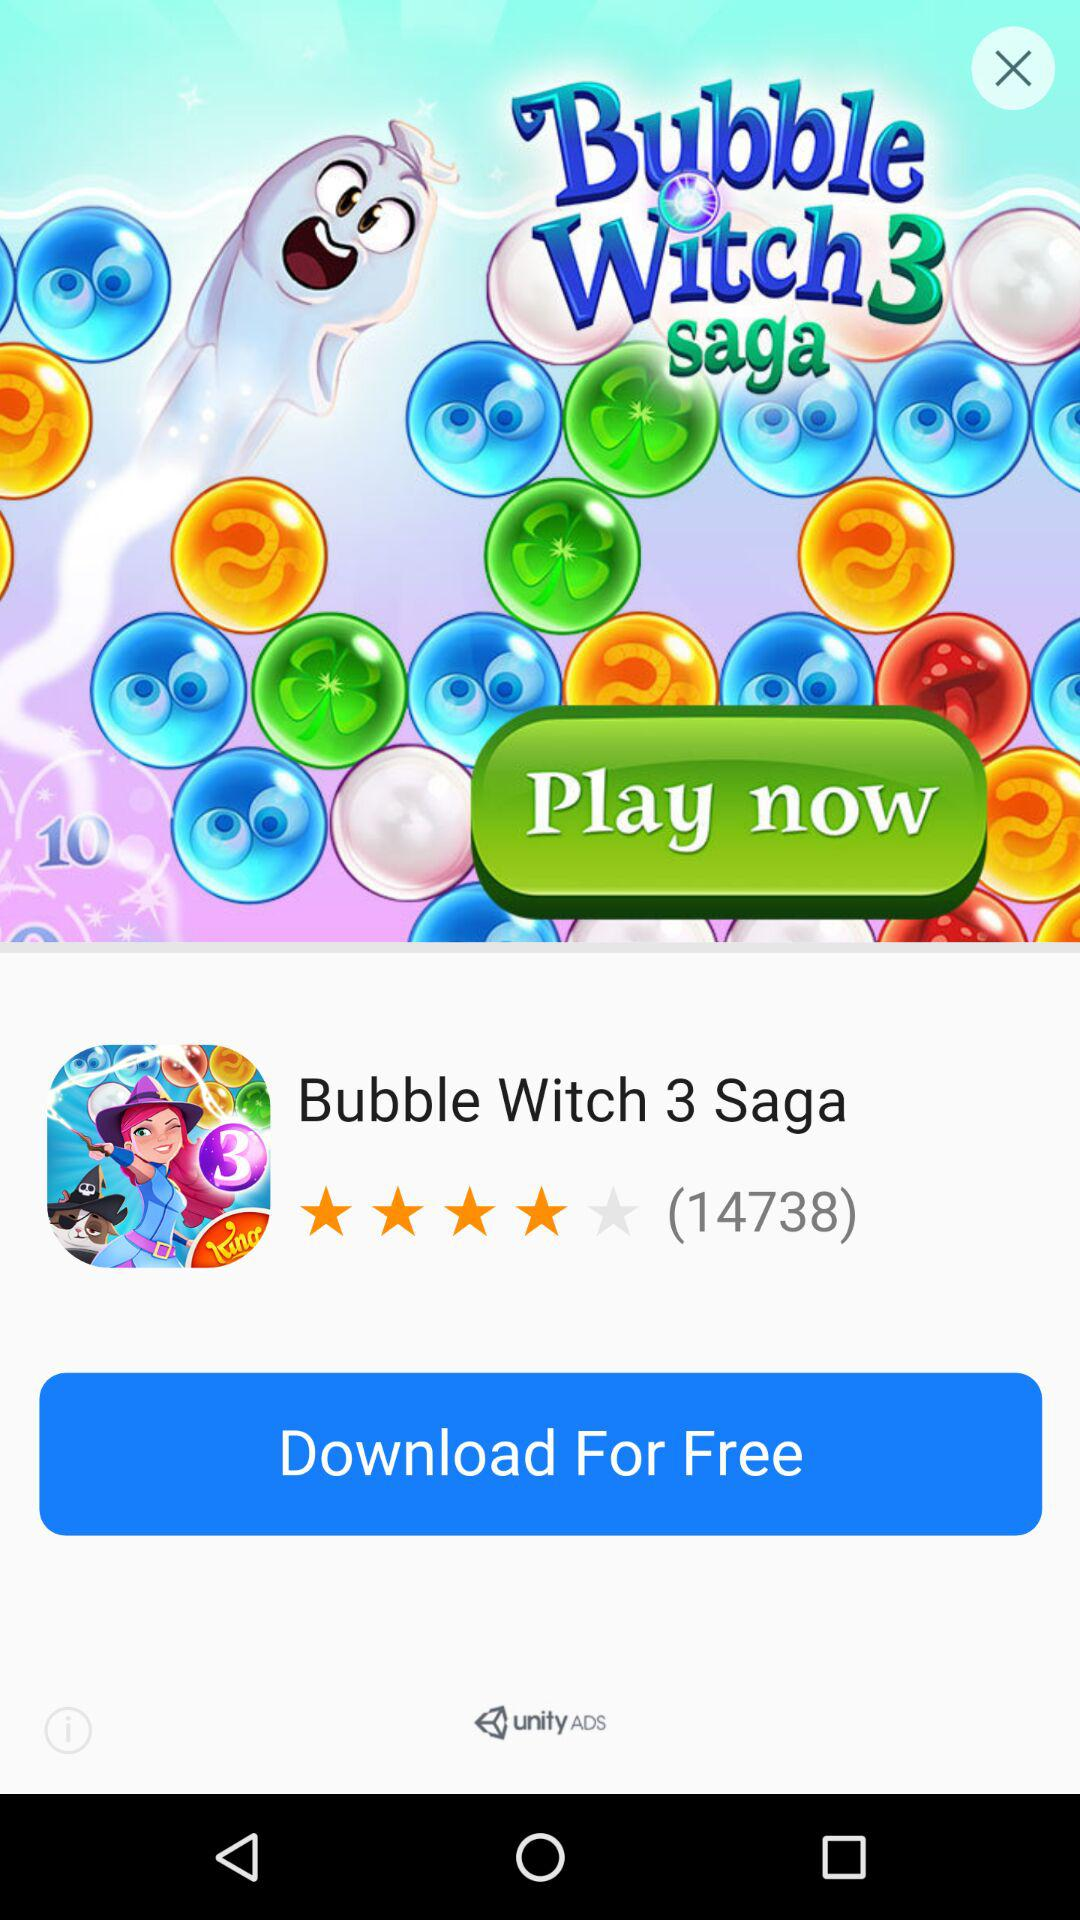Is the download free or paid? The download is "Free". 